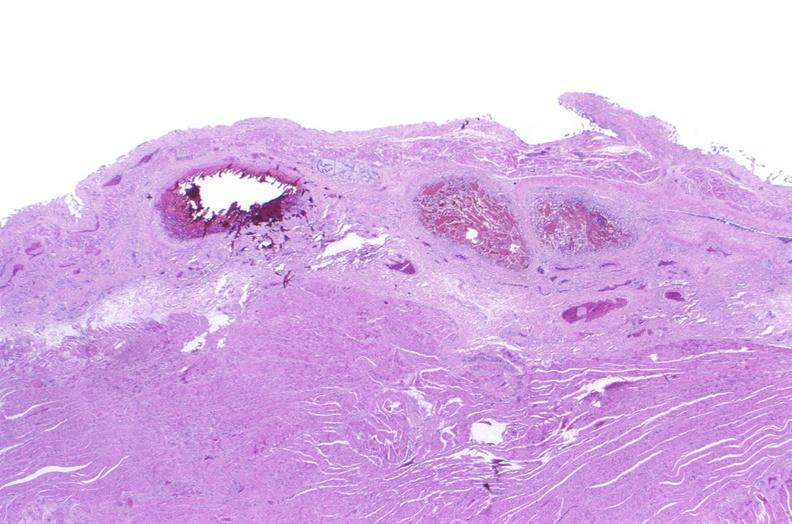does anomalous origin show esophagus, varices?
Answer the question using a single word or phrase. No 